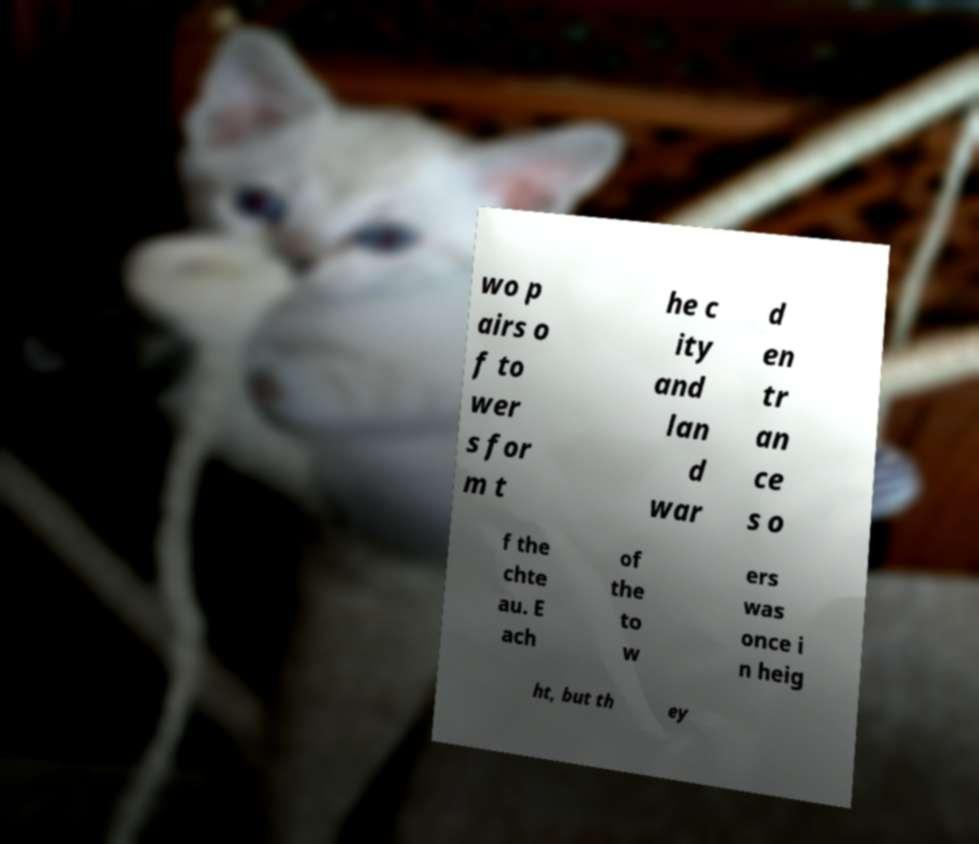Could you assist in decoding the text presented in this image and type it out clearly? wo p airs o f to wer s for m t he c ity and lan d war d en tr an ce s o f the chte au. E ach of the to w ers was once i n heig ht, but th ey 